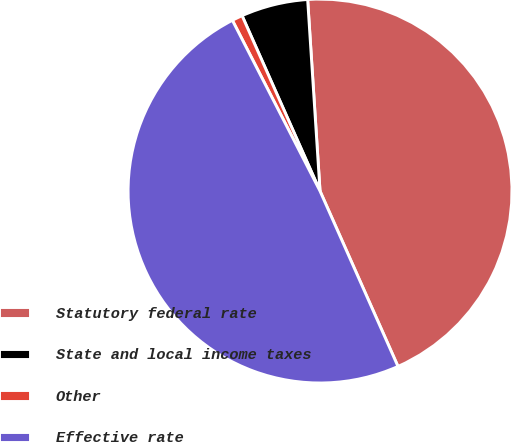<chart> <loc_0><loc_0><loc_500><loc_500><pie_chart><fcel>Statutory federal rate<fcel>State and local income taxes<fcel>Other<fcel>Effective rate<nl><fcel>44.37%<fcel>5.63%<fcel>0.89%<fcel>49.11%<nl></chart> 